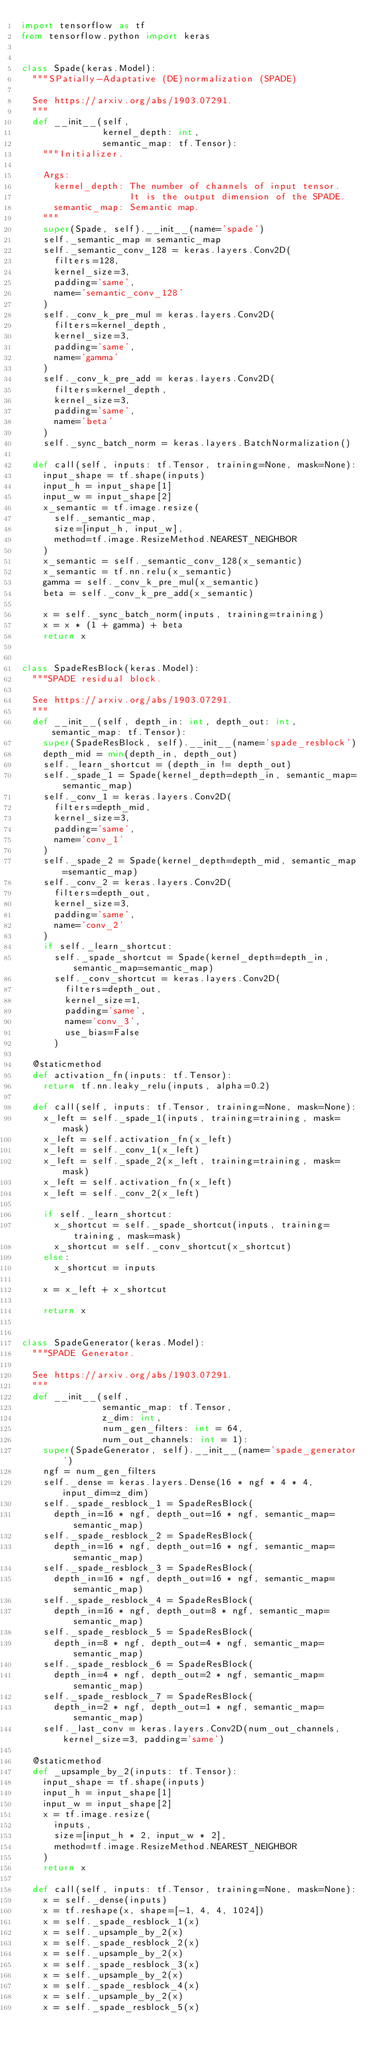Convert code to text. <code><loc_0><loc_0><loc_500><loc_500><_Python_>import tensorflow as tf
from tensorflow.python import keras


class Spade(keras.Model):
  """SPatially-Adaptative (DE)normalization (SPADE)

  See https://arxiv.org/abs/1903.07291.
  """
  def __init__(self,
               kernel_depth: int,
               semantic_map: tf.Tensor):
    """Initializer.

    Args:
      kernel_depth: The number of channels of input tensor.
                    It is the output dimension of the SPADE.
      semantic_map: Semantic map.
    """
    super(Spade, self).__init__(name='spade')
    self._semantic_map = semantic_map
    self._semantic_conv_128 = keras.layers.Conv2D(
      filters=128,
      kernel_size=3,
      padding='same',
      name='semantic_conv_128'
    )
    self._conv_k_pre_mul = keras.layers.Conv2D(
      filters=kernel_depth,
      kernel_size=3,
      padding='same',
      name='gamma'
    )
    self._conv_k_pre_add = keras.layers.Conv2D(
      filters=kernel_depth,
      kernel_size=3,
      padding='same',
      name='beta'
    )
    self._sync_batch_norm = keras.layers.BatchNormalization()

  def call(self, inputs: tf.Tensor, training=None, mask=None):
    input_shape = tf.shape(inputs)
    input_h = input_shape[1]
    input_w = input_shape[2]
    x_semantic = tf.image.resize(
      self._semantic_map,
      size=[input_h, input_w],
      method=tf.image.ResizeMethod.NEAREST_NEIGHBOR
    )
    x_semantic = self._semantic_conv_128(x_semantic)
    x_semantic = tf.nn.relu(x_semantic)
    gamma = self._conv_k_pre_mul(x_semantic)
    beta = self._conv_k_pre_add(x_semantic)

    x = self._sync_batch_norm(inputs, training=training)
    x = x * (1 + gamma) + beta
    return x


class SpadeResBlock(keras.Model):
  """SPADE residual block.

  See https://arxiv.org/abs/1903.07291.
  """
  def __init__(self, depth_in: int, depth_out: int, semantic_map: tf.Tensor):
    super(SpadeResBlock, self).__init__(name='spade_resblock')
    depth_mid = min(depth_in, depth_out)
    self._learn_shortcut = (depth_in != depth_out)
    self._spade_1 = Spade(kernel_depth=depth_in, semantic_map=semantic_map)
    self._conv_1 = keras.layers.Conv2D(
      filters=depth_mid,
      kernel_size=3,
      padding='same',
      name='conv_1'
    )
    self._spade_2 = Spade(kernel_depth=depth_mid, semantic_map=semantic_map)
    self._conv_2 = keras.layers.Conv2D(
      filters=depth_out,
      kernel_size=3,
      padding='same',
      name='conv_2'
    )
    if self._learn_shortcut:
      self._spade_shortcut = Spade(kernel_depth=depth_in, semantic_map=semantic_map)
      self._conv_shortcut = keras.layers.Conv2D(
        filters=depth_out,
        kernel_size=1,
        padding='same',
        name='conv_3',
        use_bias=False
      )

  @staticmethod
  def activation_fn(inputs: tf.Tensor):
    return tf.nn.leaky_relu(inputs, alpha=0.2)

  def call(self, inputs: tf.Tensor, training=None, mask=None):
    x_left = self._spade_1(inputs, training=training, mask=mask)
    x_left = self.activation_fn(x_left)
    x_left = self._conv_1(x_left)
    x_left = self._spade_2(x_left, training=training, mask=mask)
    x_left = self.activation_fn(x_left)
    x_left = self._conv_2(x_left)

    if self._learn_shortcut:
      x_shortcut = self._spade_shortcut(inputs, training=training, mask=mask)
      x_shortcut = self._conv_shortcut(x_shortcut)
    else:
      x_shortcut = inputs

    x = x_left + x_shortcut

    return x


class SpadeGenerator(keras.Model):
  """SPADE Generator.

  See https://arxiv.org/abs/1903.07291.
  """
  def __init__(self,
               semantic_map: tf.Tensor,
               z_dim: int,
               num_gen_filters: int = 64,
               num_out_channels: int = 1):
    super(SpadeGenerator, self).__init__(name='spade_generator')
    ngf = num_gen_filters
    self._dense = keras.layers.Dense(16 * ngf * 4 * 4, input_dim=z_dim)
    self._spade_resblock_1 = SpadeResBlock(
      depth_in=16 * ngf, depth_out=16 * ngf, semantic_map=semantic_map)
    self._spade_resblock_2 = SpadeResBlock(
      depth_in=16 * ngf, depth_out=16 * ngf, semantic_map=semantic_map)
    self._spade_resblock_3 = SpadeResBlock(
      depth_in=16 * ngf, depth_out=16 * ngf, semantic_map=semantic_map)
    self._spade_resblock_4 = SpadeResBlock(
      depth_in=16 * ngf, depth_out=8 * ngf, semantic_map=semantic_map)
    self._spade_resblock_5 = SpadeResBlock(
      depth_in=8 * ngf, depth_out=4 * ngf, semantic_map=semantic_map)
    self._spade_resblock_6 = SpadeResBlock(
      depth_in=4 * ngf, depth_out=2 * ngf, semantic_map=semantic_map)
    self._spade_resblock_7 = SpadeResBlock(
      depth_in=2 * ngf, depth_out=1 * ngf, semantic_map=semantic_map)
    self._last_conv = keras.layers.Conv2D(num_out_channels, kernel_size=3, padding='same')

  @staticmethod
  def _upsample_by_2(inputs: tf.Tensor):
    input_shape = tf.shape(inputs)
    input_h = input_shape[1]
    input_w = input_shape[2]
    x = tf.image.resize(
      inputs,
      size=[input_h * 2, input_w * 2],
      method=tf.image.ResizeMethod.NEAREST_NEIGHBOR
    )
    return x

  def call(self, inputs: tf.Tensor, training=None, mask=None):
    x = self._dense(inputs)
    x = tf.reshape(x, shape=[-1, 4, 4, 1024])
    x = self._spade_resblock_1(x)
    x = self._upsample_by_2(x)
    x = self._spade_resblock_2(x)
    x = self._upsample_by_2(x)
    x = self._spade_resblock_3(x)
    x = self._upsample_by_2(x)
    x = self._spade_resblock_4(x)
    x = self._upsample_by_2(x)
    x = self._spade_resblock_5(x)</code> 